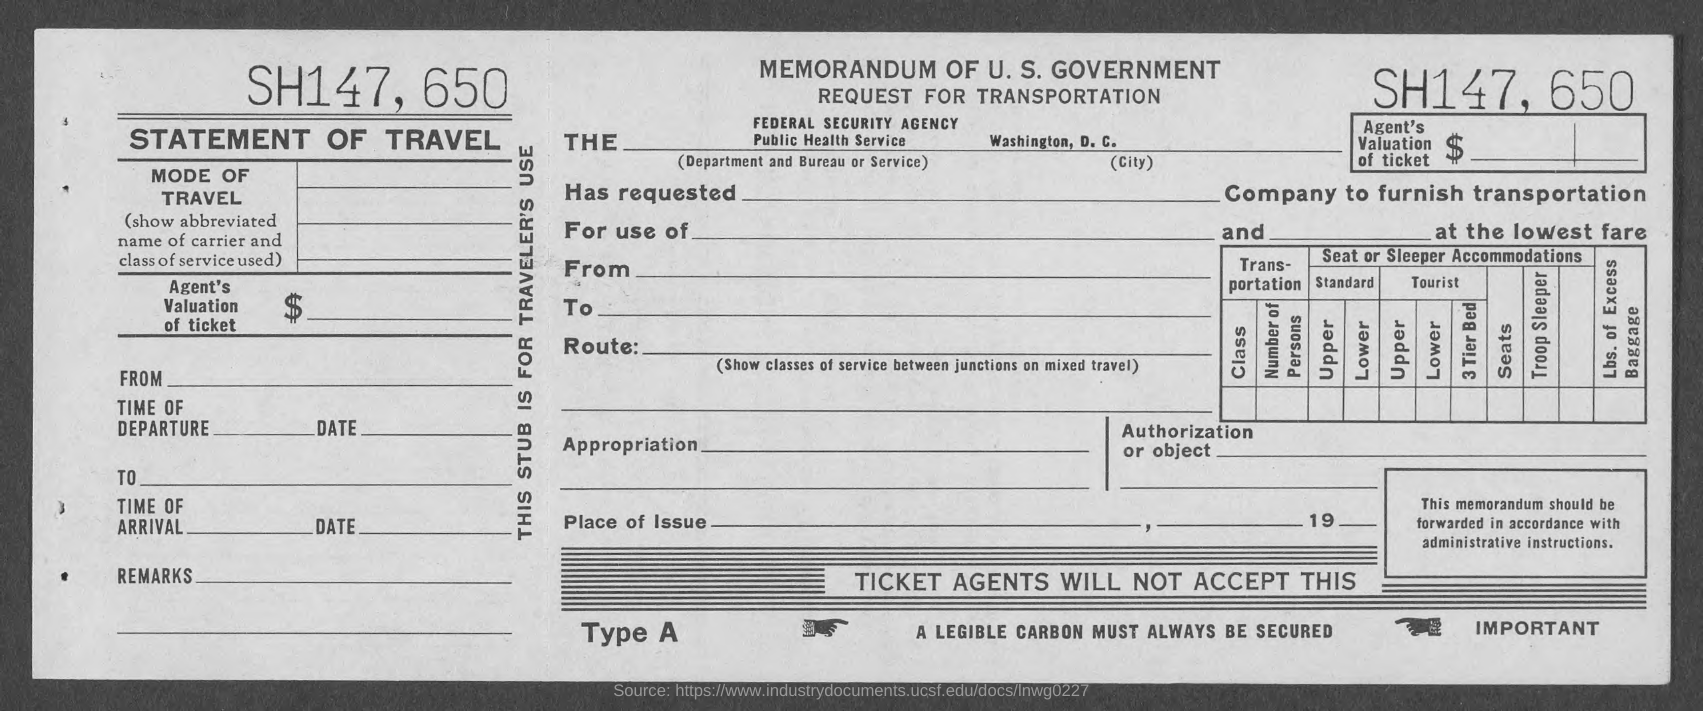What type of statement is given here?
Provide a succinct answer. Statement of Travel. 